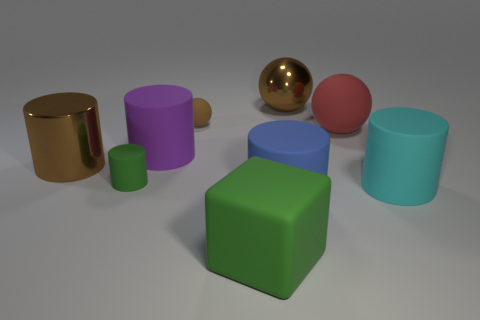What is the material of the cyan thing that is the same shape as the big blue matte object?
Your answer should be compact. Rubber. Is the small matte ball the same color as the shiny sphere?
Keep it short and to the point. Yes. There is a matte cylinder that is both in front of the large purple thing and left of the blue matte thing; what size is it?
Offer a very short reply. Small. What color is the large sphere that is the same material as the large green thing?
Keep it short and to the point. Red. What number of other big blocks are made of the same material as the large cube?
Keep it short and to the point. 0. Are there the same number of rubber cylinders that are to the left of the large red ball and tiny matte objects that are behind the brown metal cylinder?
Keep it short and to the point. No. Is the shape of the cyan thing the same as the large brown thing in front of the red rubber ball?
Make the answer very short. Yes. What is the material of the block that is the same color as the small cylinder?
Your answer should be very brief. Rubber. Are there any other things that are the same shape as the large green object?
Provide a short and direct response. No. Do the red sphere and the large object that is behind the tiny rubber sphere have the same material?
Your answer should be compact. No. 